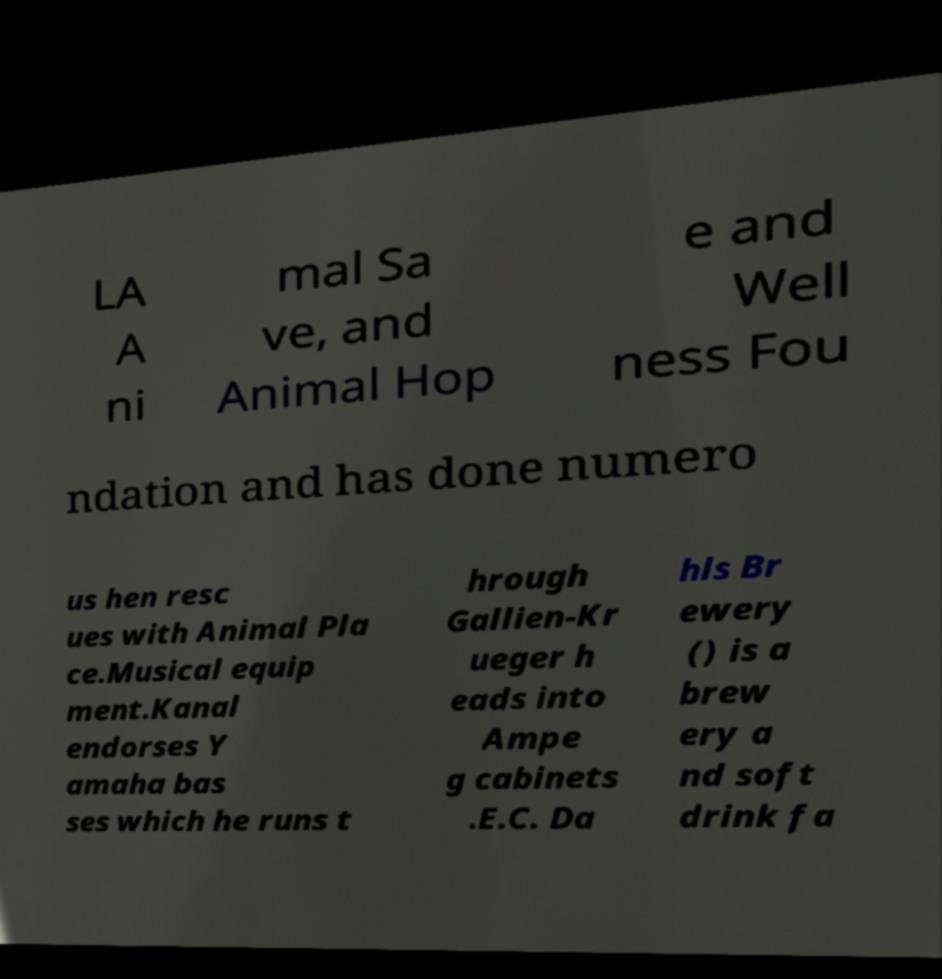What messages or text are displayed in this image? I need them in a readable, typed format. LA A ni mal Sa ve, and Animal Hop e and Well ness Fou ndation and has done numero us hen resc ues with Animal Pla ce.Musical equip ment.Kanal endorses Y amaha bas ses which he runs t hrough Gallien-Kr ueger h eads into Ampe g cabinets .E.C. Da hls Br ewery () is a brew ery a nd soft drink fa 